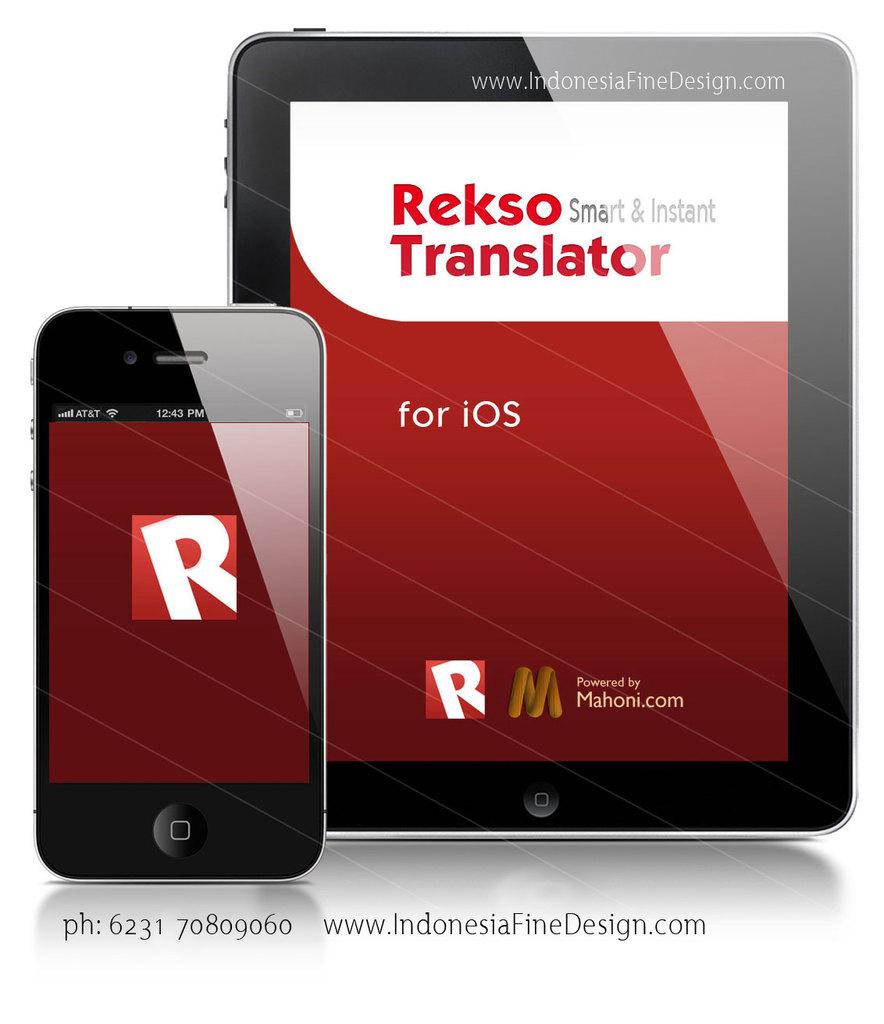What operating system is this app for?
Your answer should be very brief. Ios. 